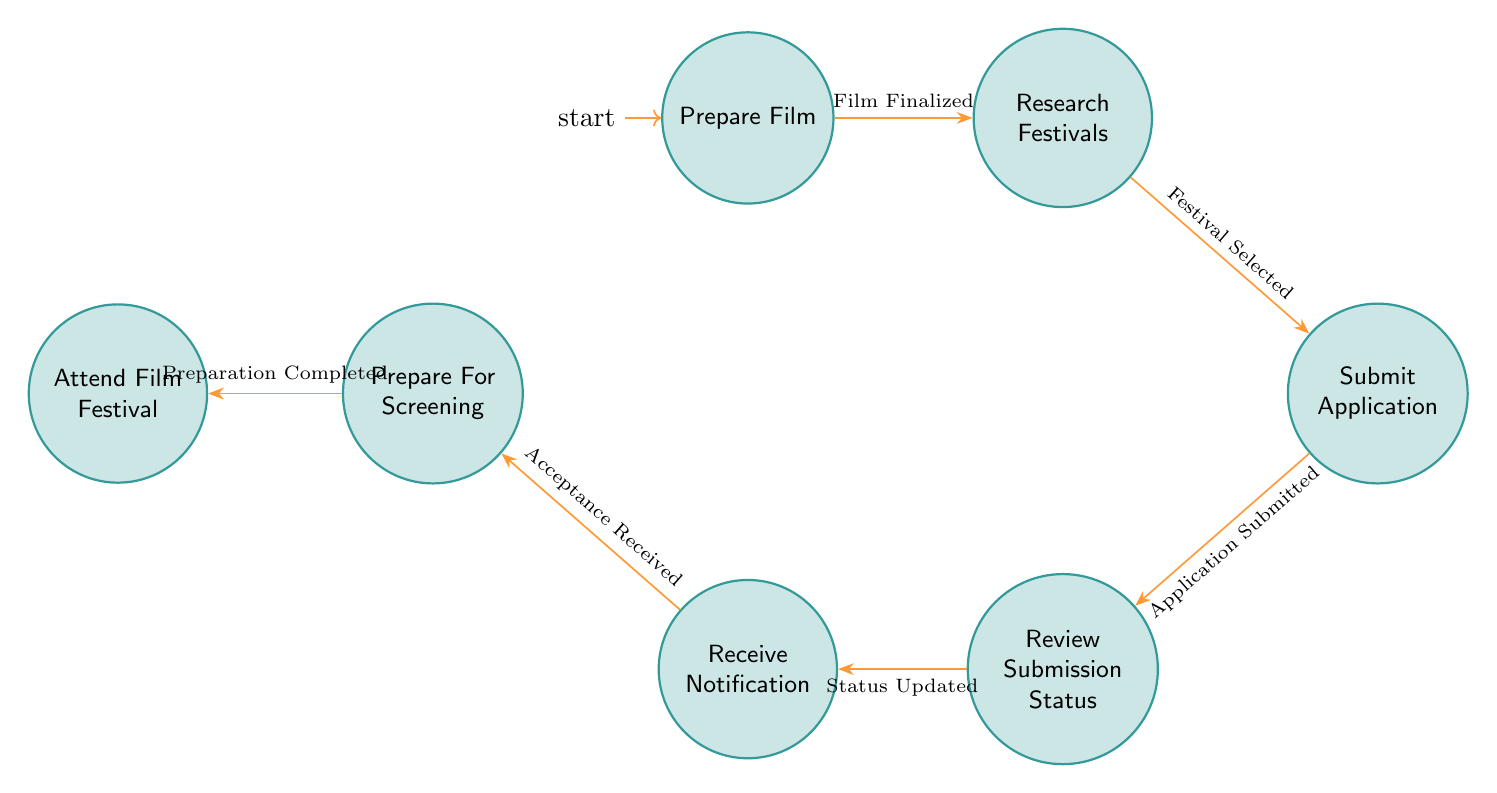What is the first state in the diagram? The first state is the initial node labeled "Prepare Film," which indicates the first step in the submission process.
Answer: Prepare Film How many total states are there? By counting the nodes in the diagram, we find there are seven states: Prepare Film, Research Festivals, Submit Application, Review Submission Status, Receive Notification, Prepare For Screening, and Attend Film Festival.
Answer: Seven What transition follows "Research Festivals"? The transition that follows "Research Festivals" is labeled "Festival Selected," leading to the "Submit Application" state.
Answer: Festival Selected What happens after "Receive Notification"? After receiving notification, the next transition is "Acceptance Received," which leads to the state "Prepare For Screening."
Answer: Prepare For Screening What is the purpose of the state "Prepare For Screening"? The state "Prepare For Screening" involves preparing all necessary materials and logistics for the screening event if accepted by the festival.
Answer: Prepare materials and logistics How many transitions are in the diagram? There are six transitions in total: Film Finalized, Festival Selected, Application Submitted, Status Updated, Acceptance Received, and Preparation Completed.
Answer: Six What is the last state in the sequence? The last state, which is the final step in the process, is "Attend Film Festival," where the filmmaker attends the festival.
Answer: Attend Film Festival If the application is submitted, what state does it lead to? Submitting the application, indicated by the transition "Application Submitted," leads to the state "Review Submission Status."
Answer: Review Submission Status What must be completed before attending the film festival? Before attending the festival, all necessary preparations indicated by the transition "Preparation Completed" must be finalized in the "Prepare For Screening" state.
Answer: Preparation Completed 